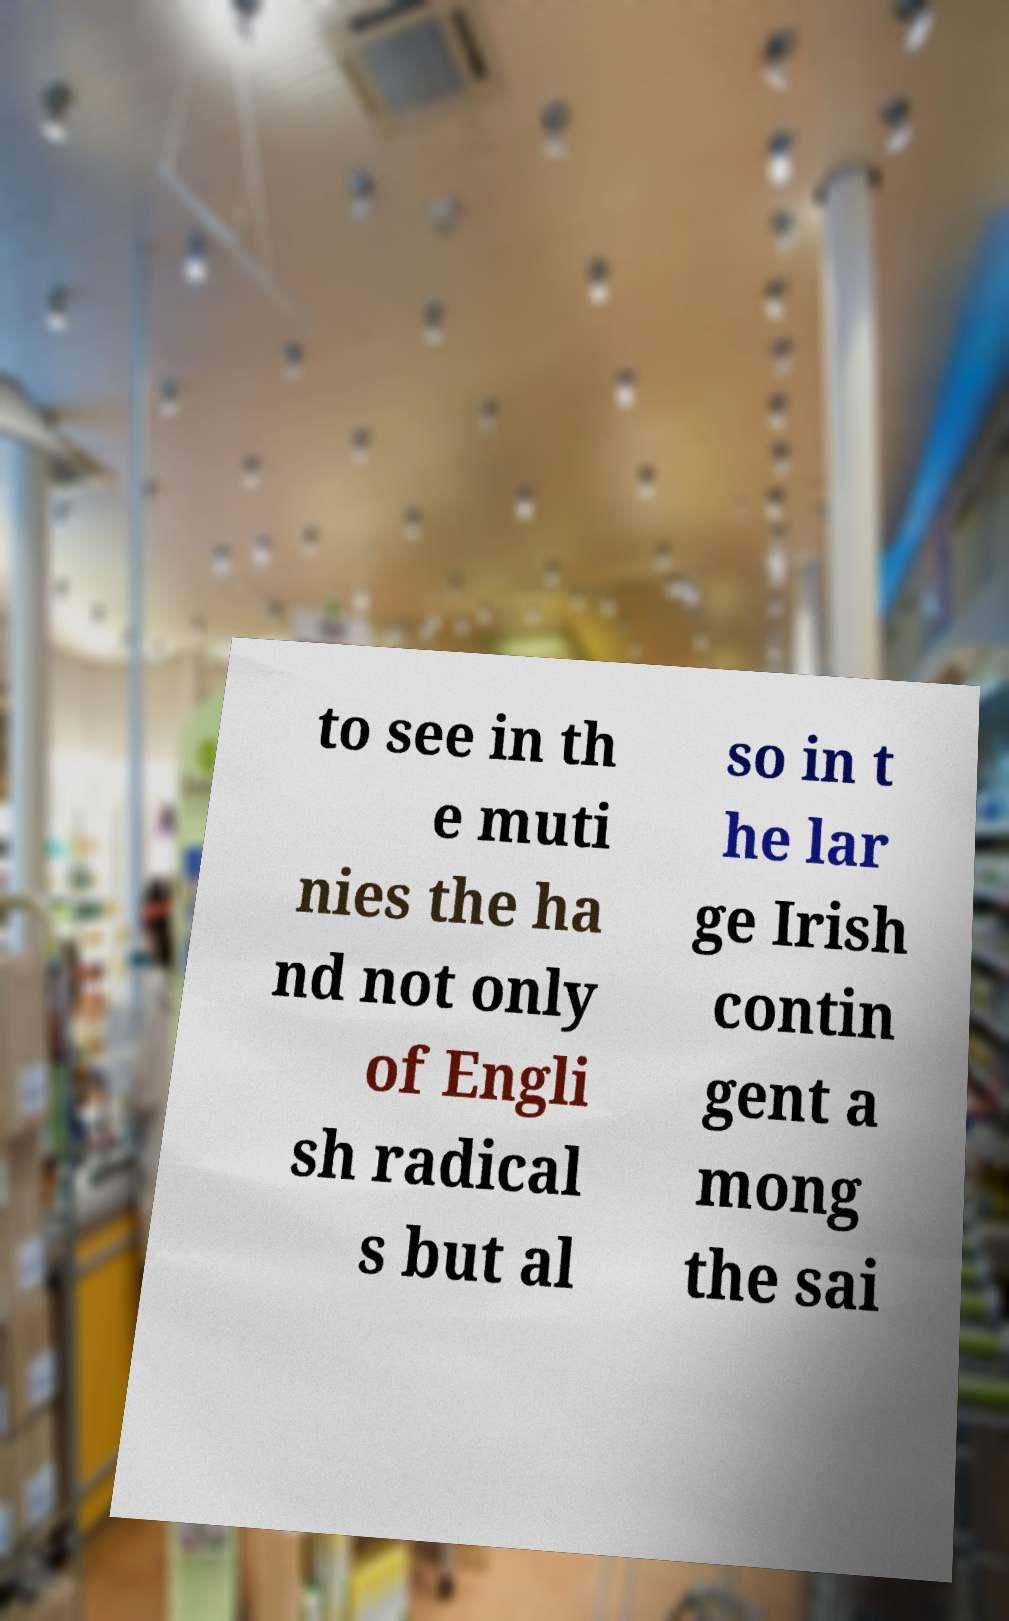Can you accurately transcribe the text from the provided image for me? to see in th e muti nies the ha nd not only of Engli sh radical s but al so in t he lar ge Irish contin gent a mong the sai 